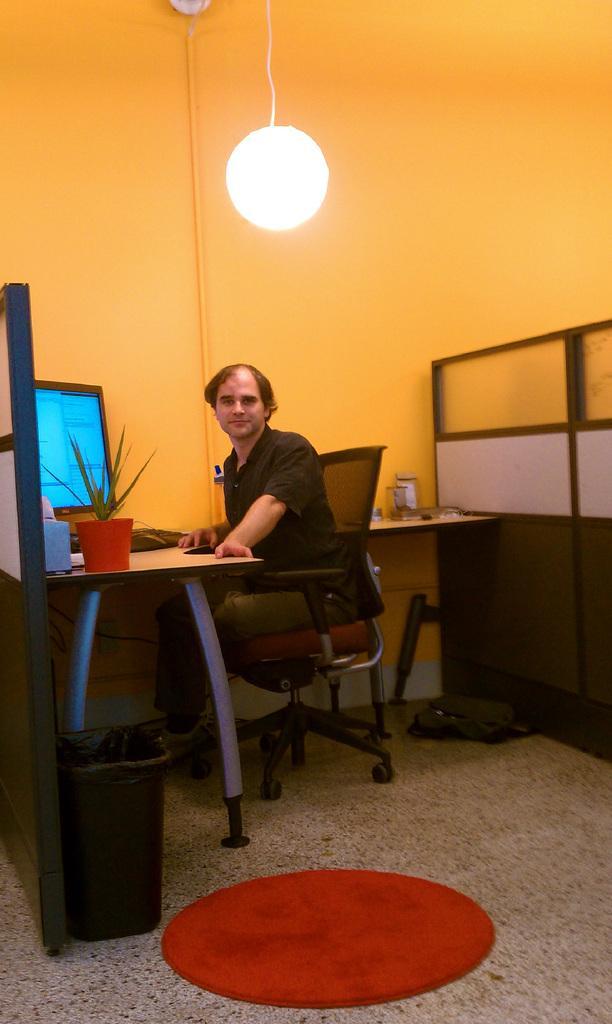Can you describe this image briefly? In this picture we can see a man who is sitting on the chair. This is table. On the table there is a monitor, keyboard, and a plant. This is floor and there is a bin. On the background we can the wall and this is light. 